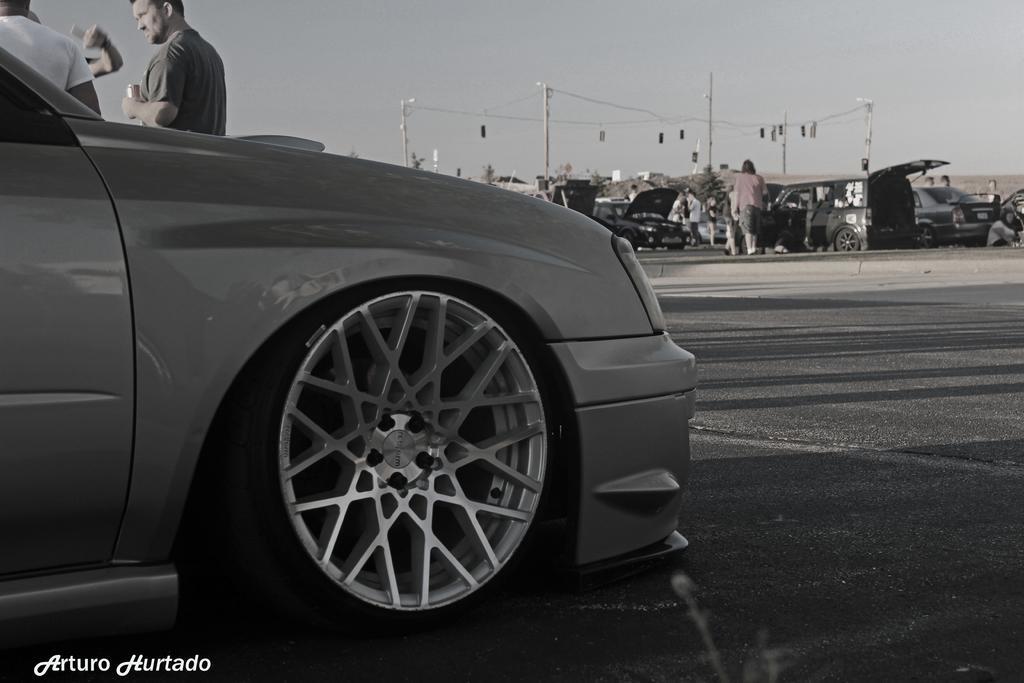How would you summarize this image in a sentence or two? In this image we can see a car parked on the road and group of vehicles placed on the road. In the background, we can see a group of people standing on the road. One person is holding can in his hand, group of poles and the sky. 